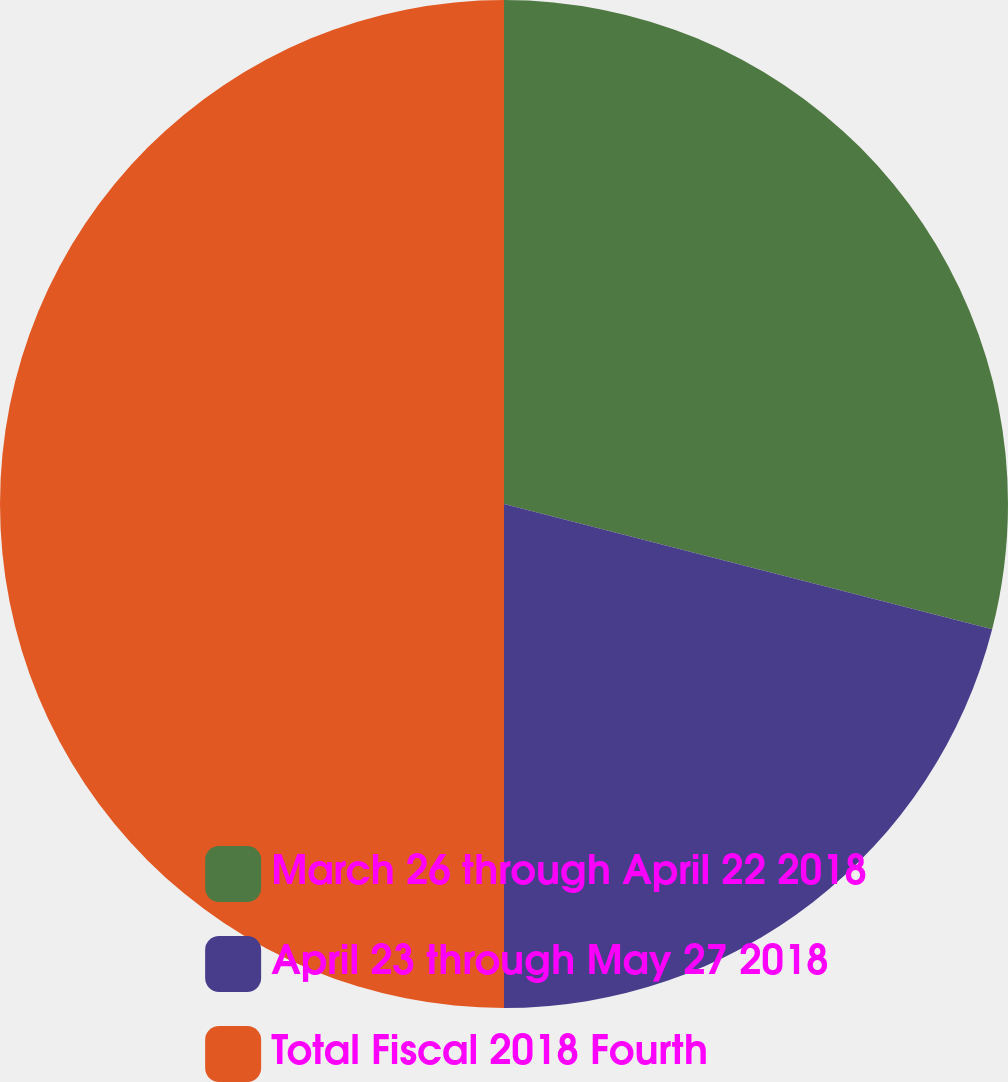Convert chart. <chart><loc_0><loc_0><loc_500><loc_500><pie_chart><fcel>March 26 through April 22 2018<fcel>April 23 through May 27 2018<fcel>Total Fiscal 2018 Fourth<nl><fcel>29.0%<fcel>21.0%<fcel>50.0%<nl></chart> 